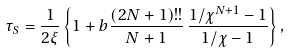<formula> <loc_0><loc_0><loc_500><loc_500>\tau _ { S } = \frac { 1 } { 2 \xi } \left \{ 1 + b \frac { ( 2 N + 1 ) ! ! } { N + 1 } \, \frac { 1 / \chi ^ { N + 1 } - 1 } { 1 / \chi - 1 } \right \} ,</formula> 